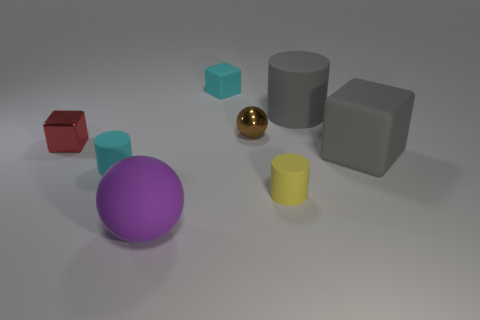Add 2 small metallic objects. How many objects exist? 10 Subtract all cylinders. How many objects are left? 5 Subtract 0 gray spheres. How many objects are left? 8 Subtract all large rubber balls. Subtract all large gray blocks. How many objects are left? 6 Add 1 gray rubber things. How many gray rubber things are left? 3 Add 5 big blue metal balls. How many big blue metal balls exist? 5 